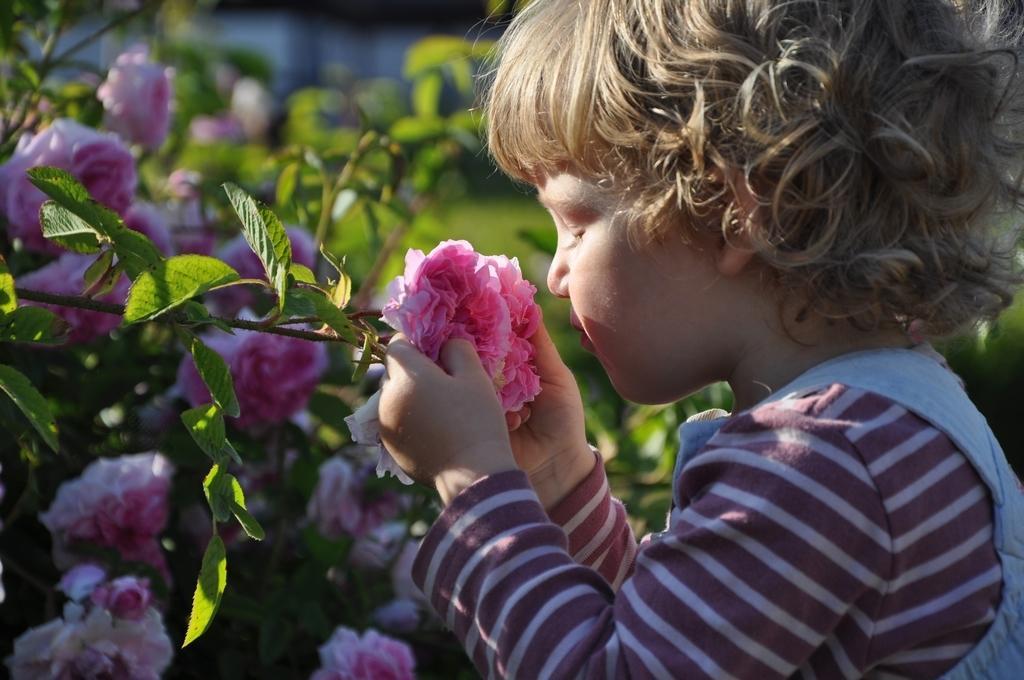In one or two sentences, can you explain what this image depicts? On the right side of the image we can see a kid is holding a flower. On the left side of the image, we can see plants with flowers. In the background, we can see it is blurred. 